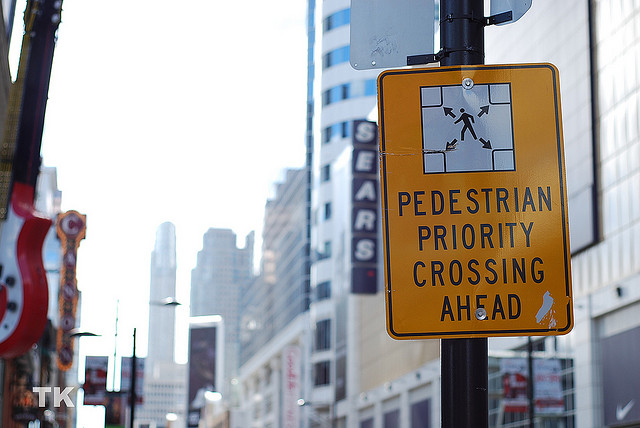Read and extract the text from this image. SEARS PEDESTRIAN PRIORITY CROSSING AHEAD TK 